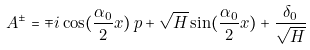Convert formula to latex. <formula><loc_0><loc_0><loc_500><loc_500>A ^ { \pm } = \mp i \cos ( \frac { \alpha _ { 0 } } { 2 } x ) \, p + \sqrt { H } \sin ( \frac { \alpha _ { 0 } } { 2 } x ) + \frac { \delta _ { 0 } } { \sqrt { H } }</formula> 